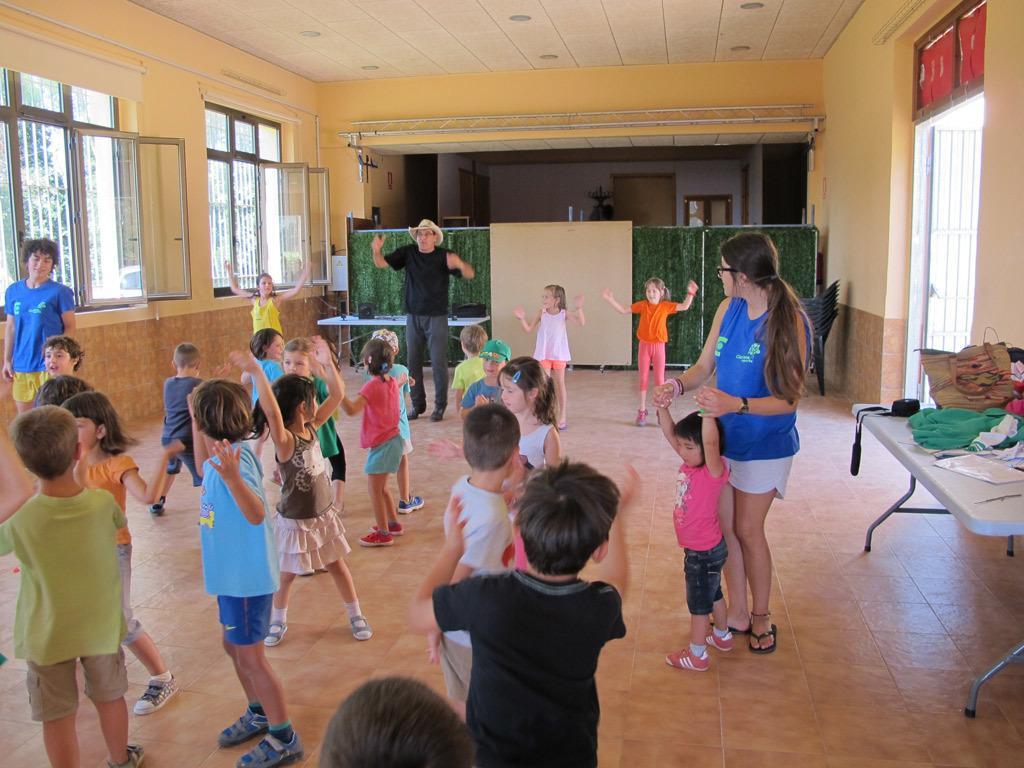Could you give a brief overview of what you see in this image? In the foreground of this image, there are kids standing and also two men and a woman. On the right there are few objects on a table. On the left, there are windows. On the top, there is the ceiling. In the background, there are curtains, a table, chairs and the wall. 